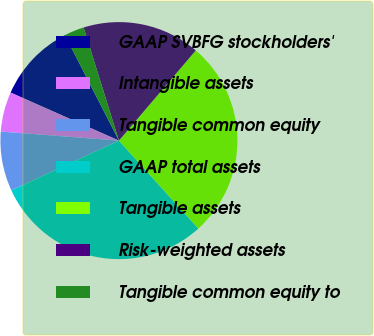Convert chart. <chart><loc_0><loc_0><loc_500><loc_500><pie_chart><fcel>GAAP SVBFG stockholders'<fcel>Intangible assets<fcel>Tangible common equity<fcel>GAAP total assets<fcel>Tangible assets<fcel>Risk-weighted assets<fcel>Tangible common equity to<nl><fcel>10.83%<fcel>5.42%<fcel>8.12%<fcel>29.79%<fcel>27.08%<fcel>16.05%<fcel>2.71%<nl></chart> 